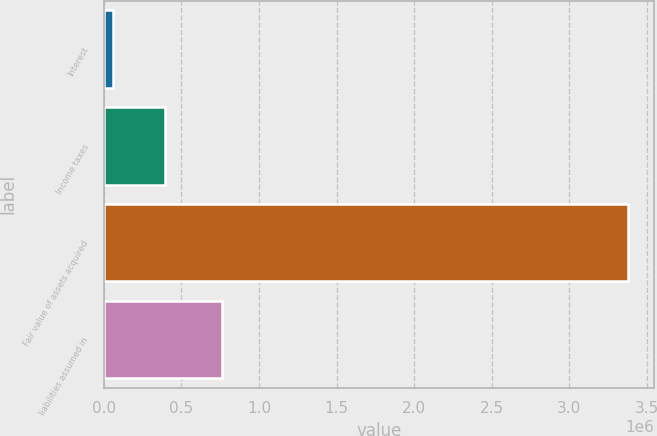<chart> <loc_0><loc_0><loc_500><loc_500><bar_chart><fcel>Interest<fcel>Income taxes<fcel>Fair value of assets acquired<fcel>liabilities assumed in<nl><fcel>61468<fcel>392882<fcel>3.3756e+06<fcel>762076<nl></chart> 